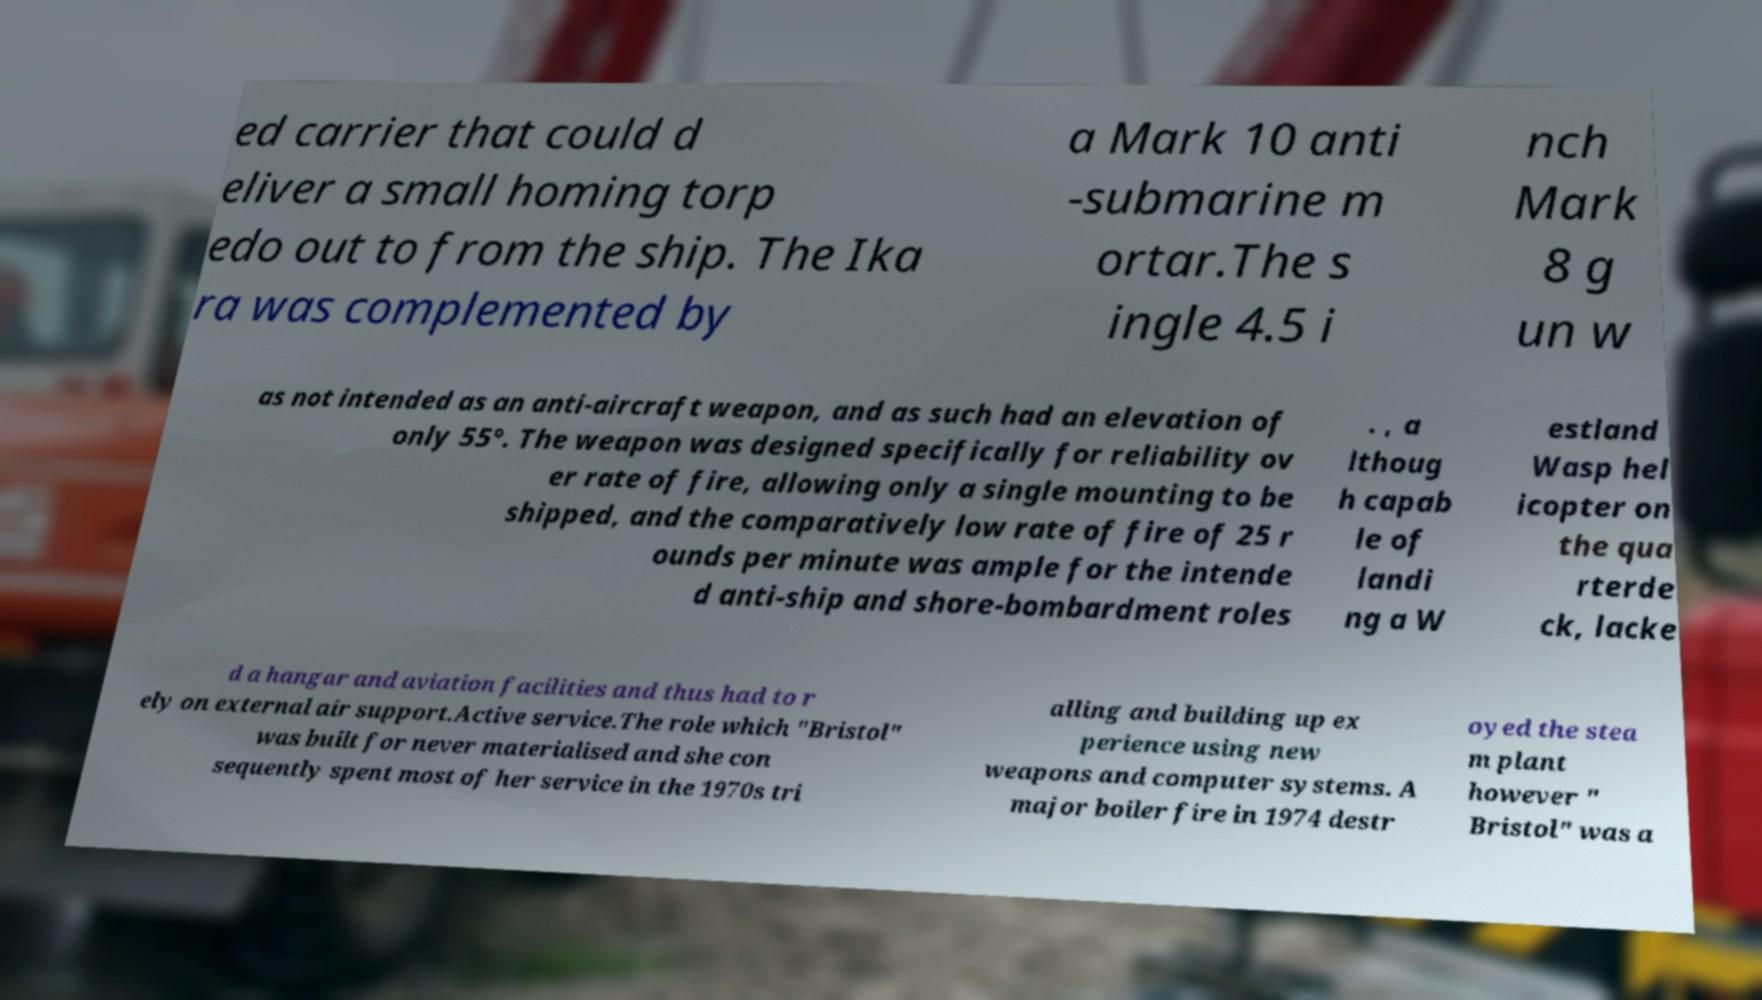Please read and relay the text visible in this image. What does it say? ed carrier that could d eliver a small homing torp edo out to from the ship. The Ika ra was complemented by a Mark 10 anti -submarine m ortar.The s ingle 4.5 i nch Mark 8 g un w as not intended as an anti-aircraft weapon, and as such had an elevation of only 55°. The weapon was designed specifically for reliability ov er rate of fire, allowing only a single mounting to be shipped, and the comparatively low rate of fire of 25 r ounds per minute was ample for the intende d anti-ship and shore-bombardment roles . , a lthoug h capab le of landi ng a W estland Wasp hel icopter on the qua rterde ck, lacke d a hangar and aviation facilities and thus had to r ely on external air support.Active service.The role which "Bristol" was built for never materialised and she con sequently spent most of her service in the 1970s tri alling and building up ex perience using new weapons and computer systems. A major boiler fire in 1974 destr oyed the stea m plant however " Bristol" was a 